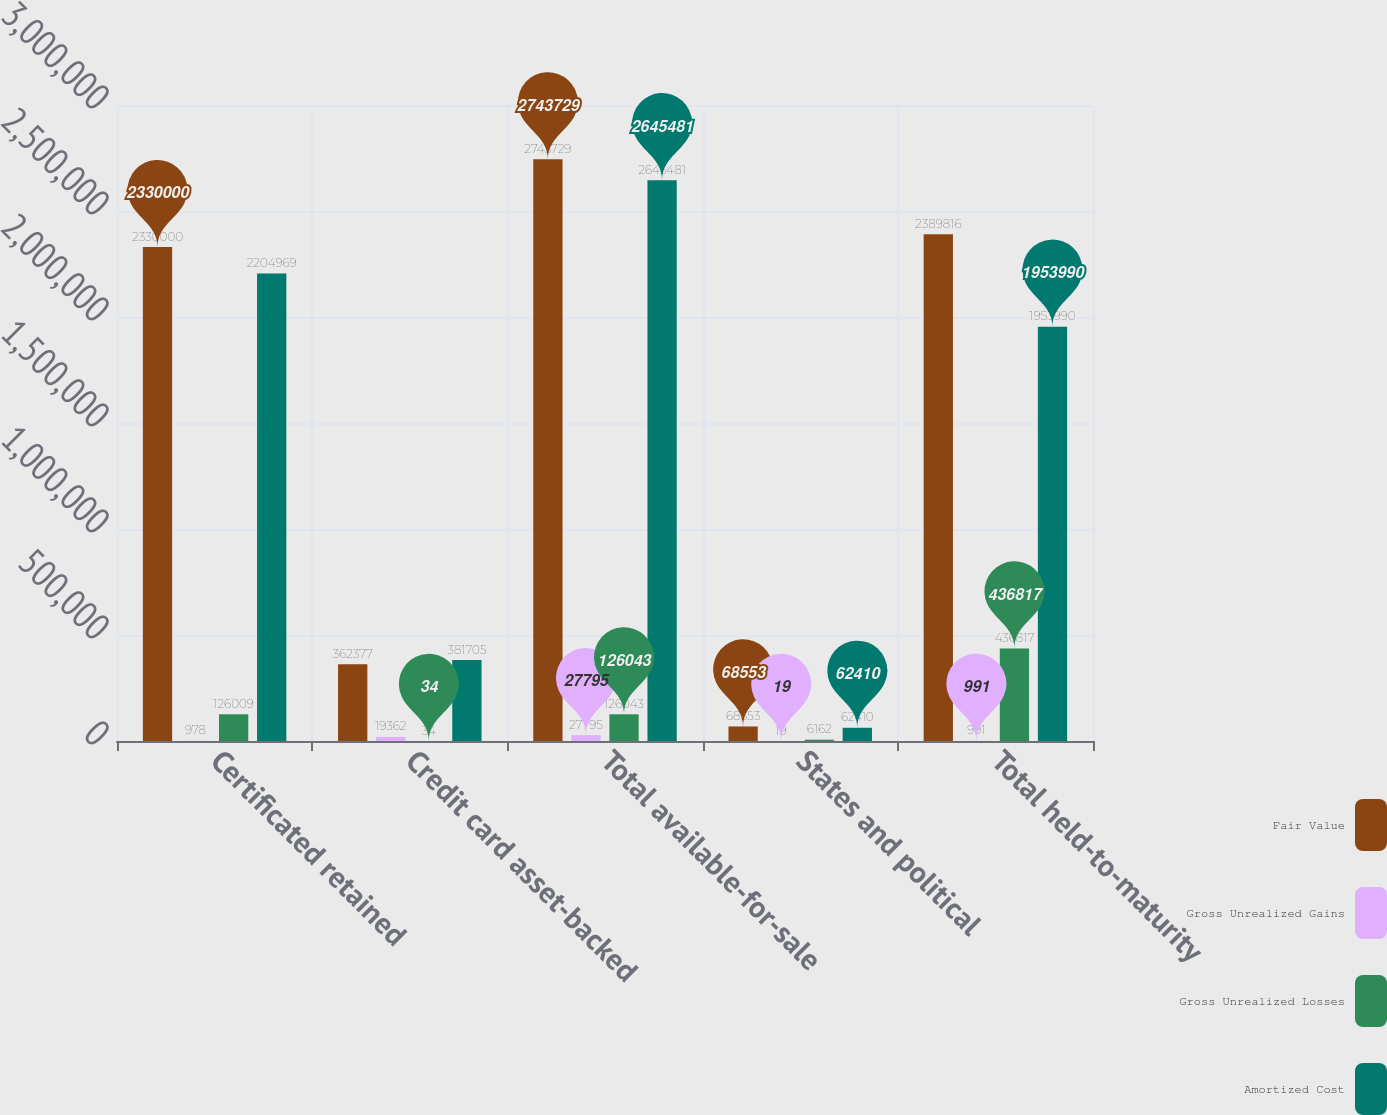<chart> <loc_0><loc_0><loc_500><loc_500><stacked_bar_chart><ecel><fcel>Certificated retained<fcel>Credit card asset-backed<fcel>Total available-for-sale<fcel>States and political<fcel>Total held-to-maturity<nl><fcel>Fair Value<fcel>2.33e+06<fcel>362377<fcel>2.74373e+06<fcel>68553<fcel>2.38982e+06<nl><fcel>Gross Unrealized Gains<fcel>978<fcel>19362<fcel>27795<fcel>19<fcel>991<nl><fcel>Gross Unrealized Losses<fcel>126009<fcel>34<fcel>126043<fcel>6162<fcel>436817<nl><fcel>Amortized Cost<fcel>2.20497e+06<fcel>381705<fcel>2.64548e+06<fcel>62410<fcel>1.95399e+06<nl></chart> 